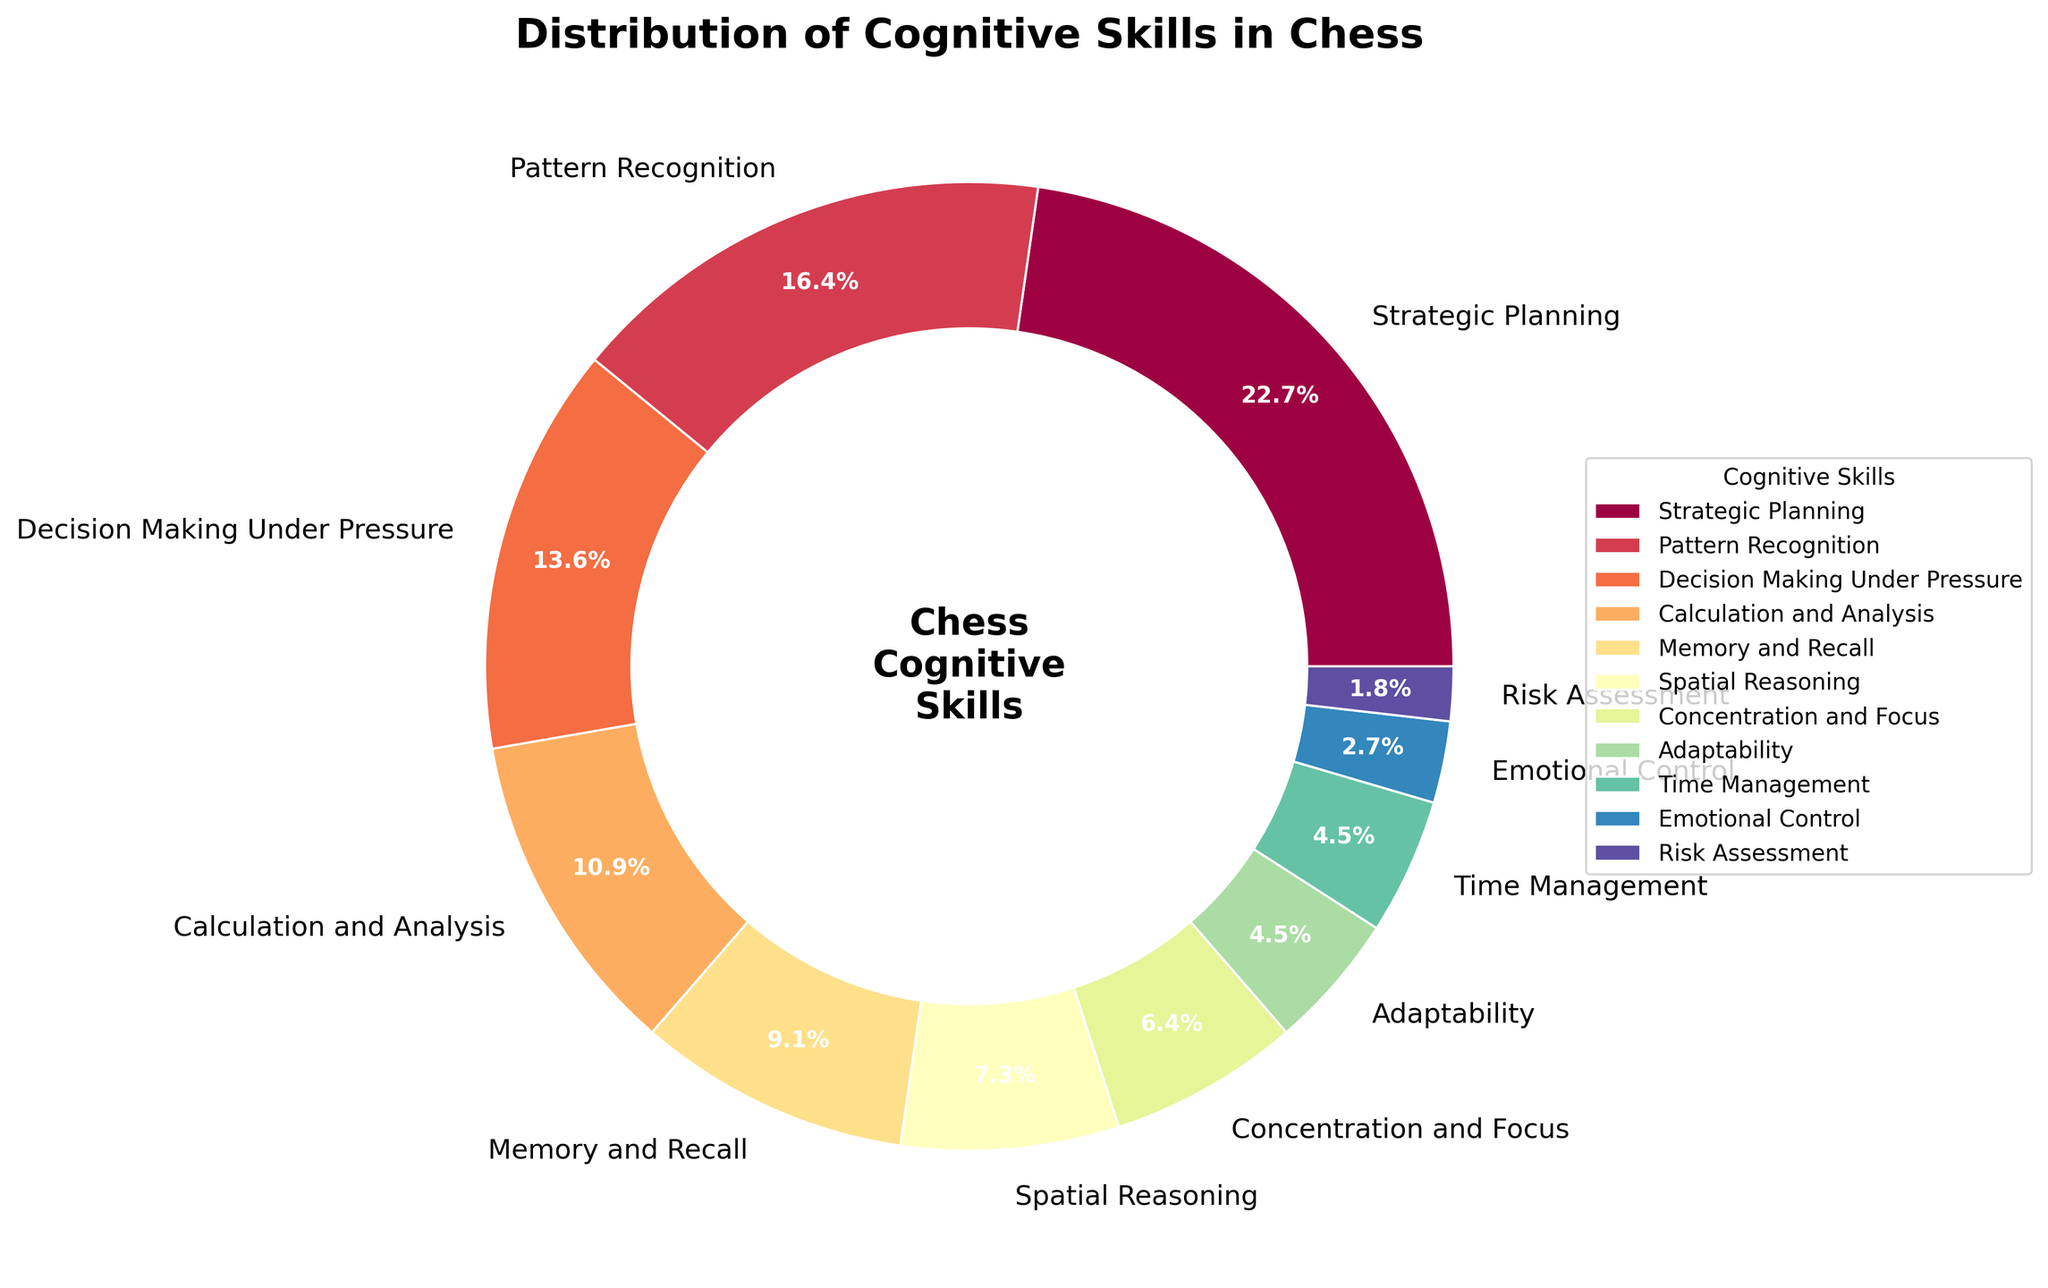What is the dominant cognitive skill utilized in chess according to the pie chart? The largest section of the pie chart represents the skill with the highest percentage. From the data, we can see that "Strategic Planning" takes up the largest slice at 25%.
Answer: Strategic Planning How much more significant is Pattern Recognition compared to Risk Assessment? Find the percentage for both skills from the chart: Pattern Recognition is 18% and Risk Assessment is 2%. The difference is 18% - 2% = 16%.
Answer: 16% What is the combined percentage of Calculation and Analysis, and Decision Making Under Pressure? Look at the pie chart and find the percentages for Calculation and Analysis (12%) and Decision Making Under Pressure (15%). Adding them together gives 12% + 15% = 27%.
Answer: 27% Which cognitive skill has the smallest representation in the pie chart? The smallest slice of the pie chart corresponds to the skill with the lowest percentage. From the data, "Risk Assessment" has the smallest percentage at 2%.
Answer: Risk Assessment Between Emotional Control and Adaptability, which skill has a higher percentage? From the chart, Emotional Control is 3% and Adaptability is 5%. Therefore, Adaptability has a higher percentage.
Answer: Adaptability What skill is indicated by the darkest color on the pie chart? Identify the darkest color on the chart, which is typically towards the end of the colormap spectrum. Based on the data, the darkest color likely corresponds to the highest percentage, which is Strategic Planning at 25%.
Answer: Strategic Planning If you combine Memory and Recall, and Spatial Reasoning, what would their total percentage be? Add the percentages for Memory and Recall (10%) and Spatial Reasoning (8%) from the chart. The total is 10% + 8% = 18%.
Answer: 18% By how much does the percentage of Concentration and Focus exceed that of Emotional Control? Concentration and Focus is 7%, while Emotional Control is 3%. The difference is 7% - 3% = 4%.
Answer: 4% What is the average percentage of the three skills with the lowest representation? The three lowest percentages are Risk Assessment (2%), Emotional Control (3%), and Time Management (5%). The total is 2% + 3% + 5% = 10%. Divide by 3 to find the average: 10% / 3 ≈ 3.33%.
Answer: 3.33% What percentage does Time Management contribute to the overall cognitive skills? From the pie chart, Time Management represents 5% of the overall cognitive skills in chess.
Answer: 5% 